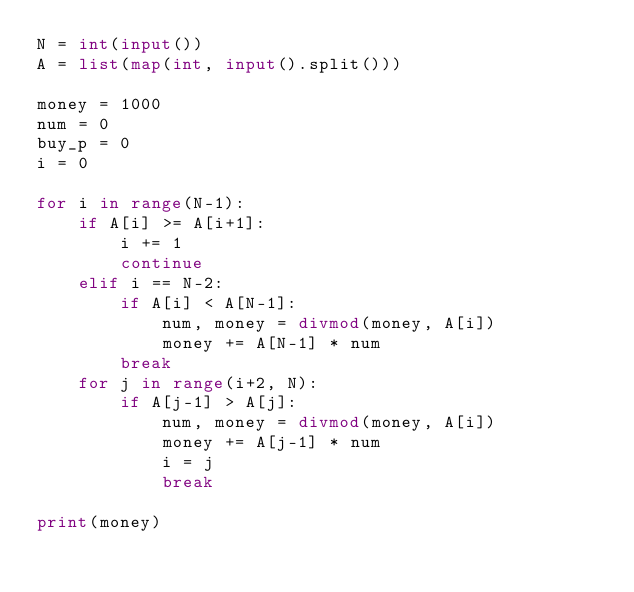<code> <loc_0><loc_0><loc_500><loc_500><_Python_>N = int(input())
A = list(map(int, input().split()))

money = 1000
num = 0
buy_p = 0
i = 0

for i in range(N-1):
    if A[i] >= A[i+1]:
        i += 1
        continue
    elif i == N-2:
        if A[i] < A[N-1]:
            num, money = divmod(money, A[i])
            money += A[N-1] * num
        break
    for j in range(i+2, N):
        if A[j-1] > A[j]:
            num, money = divmod(money, A[i])
            money += A[j-1] * num
            i = j
            break

print(money)
</code> 